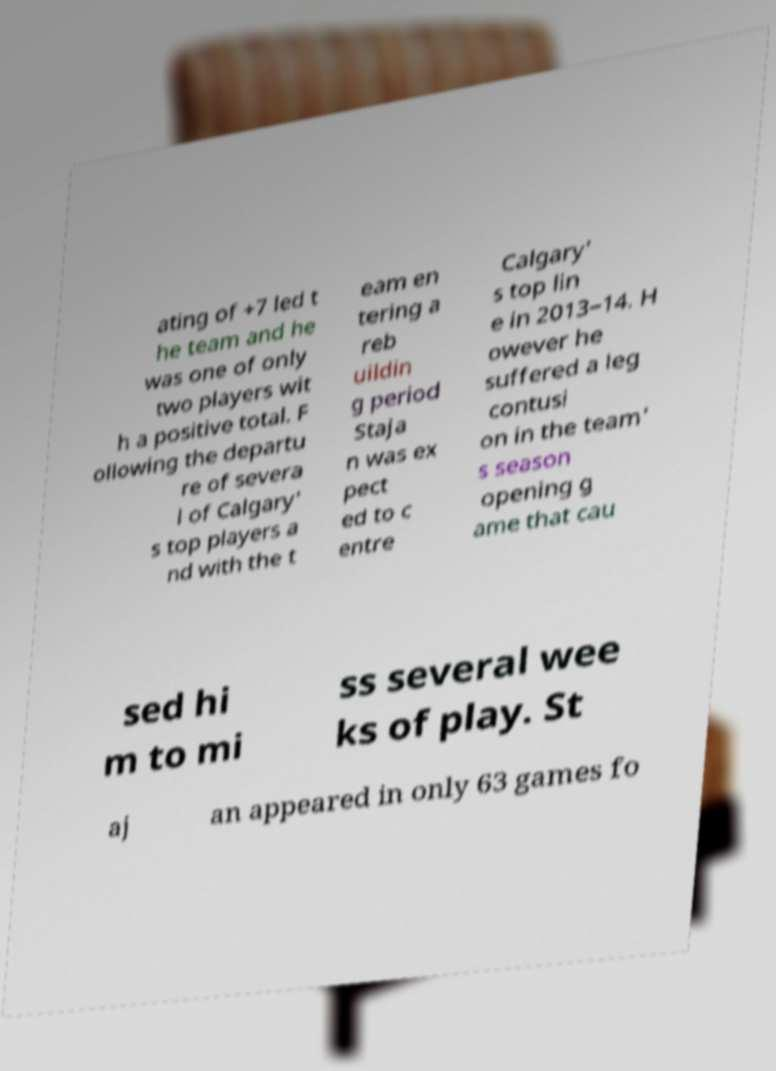For documentation purposes, I need the text within this image transcribed. Could you provide that? ating of +7 led t he team and he was one of only two players wit h a positive total. F ollowing the departu re of severa l of Calgary' s top players a nd with the t eam en tering a reb uildin g period Staja n was ex pect ed to c entre Calgary' s top lin e in 2013–14. H owever he suffered a leg contusi on in the team' s season opening g ame that cau sed hi m to mi ss several wee ks of play. St aj an appeared in only 63 games fo 